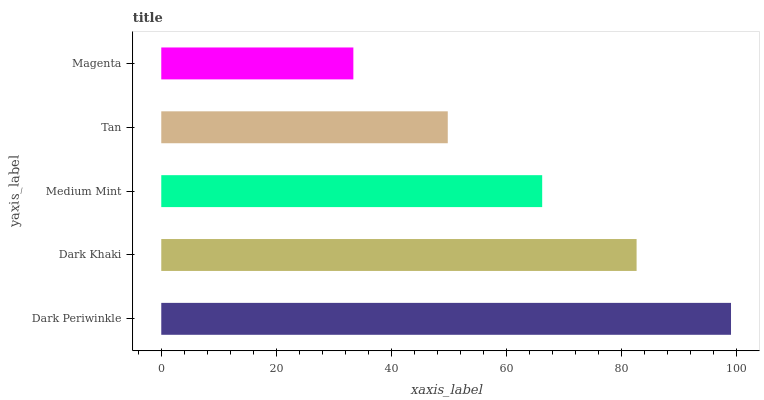Is Magenta the minimum?
Answer yes or no. Yes. Is Dark Periwinkle the maximum?
Answer yes or no. Yes. Is Dark Khaki the minimum?
Answer yes or no. No. Is Dark Khaki the maximum?
Answer yes or no. No. Is Dark Periwinkle greater than Dark Khaki?
Answer yes or no. Yes. Is Dark Khaki less than Dark Periwinkle?
Answer yes or no. Yes. Is Dark Khaki greater than Dark Periwinkle?
Answer yes or no. No. Is Dark Periwinkle less than Dark Khaki?
Answer yes or no. No. Is Medium Mint the high median?
Answer yes or no. Yes. Is Medium Mint the low median?
Answer yes or no. Yes. Is Dark Khaki the high median?
Answer yes or no. No. Is Tan the low median?
Answer yes or no. No. 